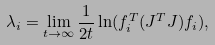Convert formula to latex. <formula><loc_0><loc_0><loc_500><loc_500>\lambda _ { i } = \lim _ { t \rightarrow \infty } \frac { 1 } { 2 t } \ln ( { f } ^ { T } _ { i } ( J ^ { T } J ) { f _ { i } } ) ,</formula> 